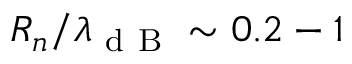<formula> <loc_0><loc_0><loc_500><loc_500>R _ { n } / \lambda _ { d B } \sim 0 . 2 - 1</formula> 